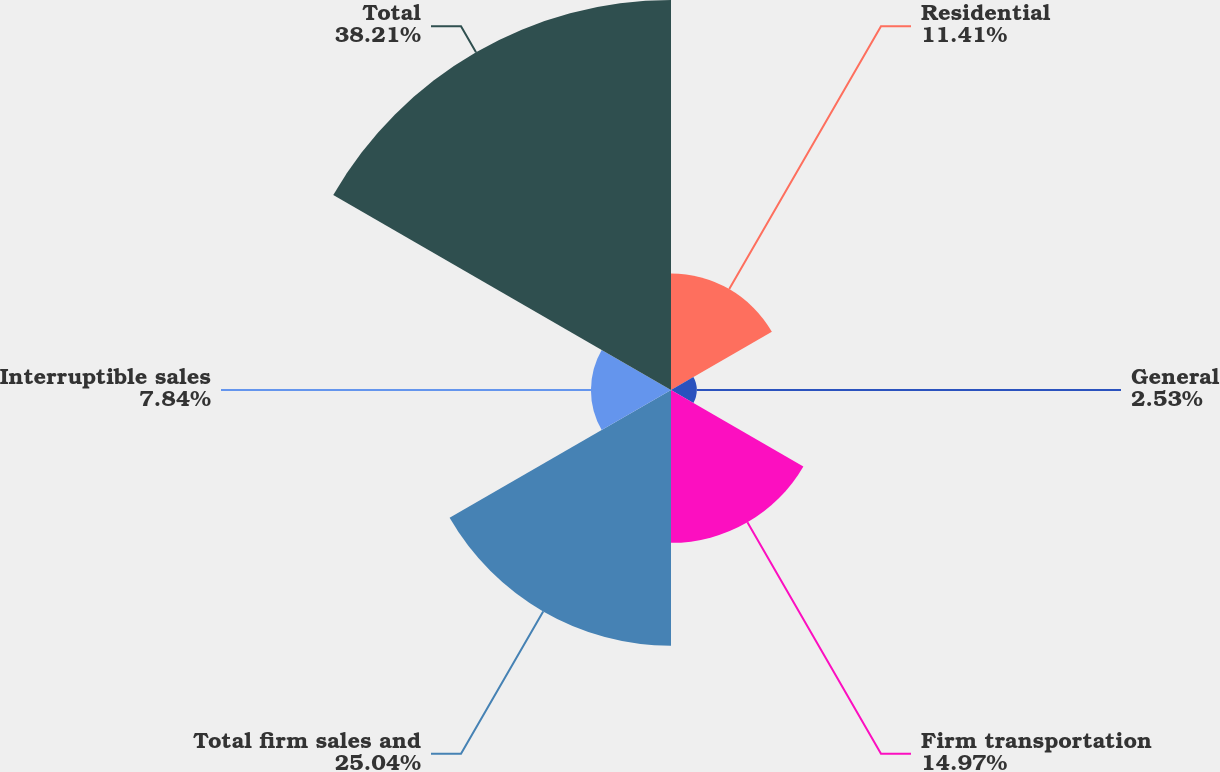<chart> <loc_0><loc_0><loc_500><loc_500><pie_chart><fcel>Residential<fcel>General<fcel>Firm transportation<fcel>Total firm sales and<fcel>Interruptible sales<fcel>Total<nl><fcel>11.41%<fcel>2.53%<fcel>14.97%<fcel>25.04%<fcel>7.84%<fcel>38.2%<nl></chart> 